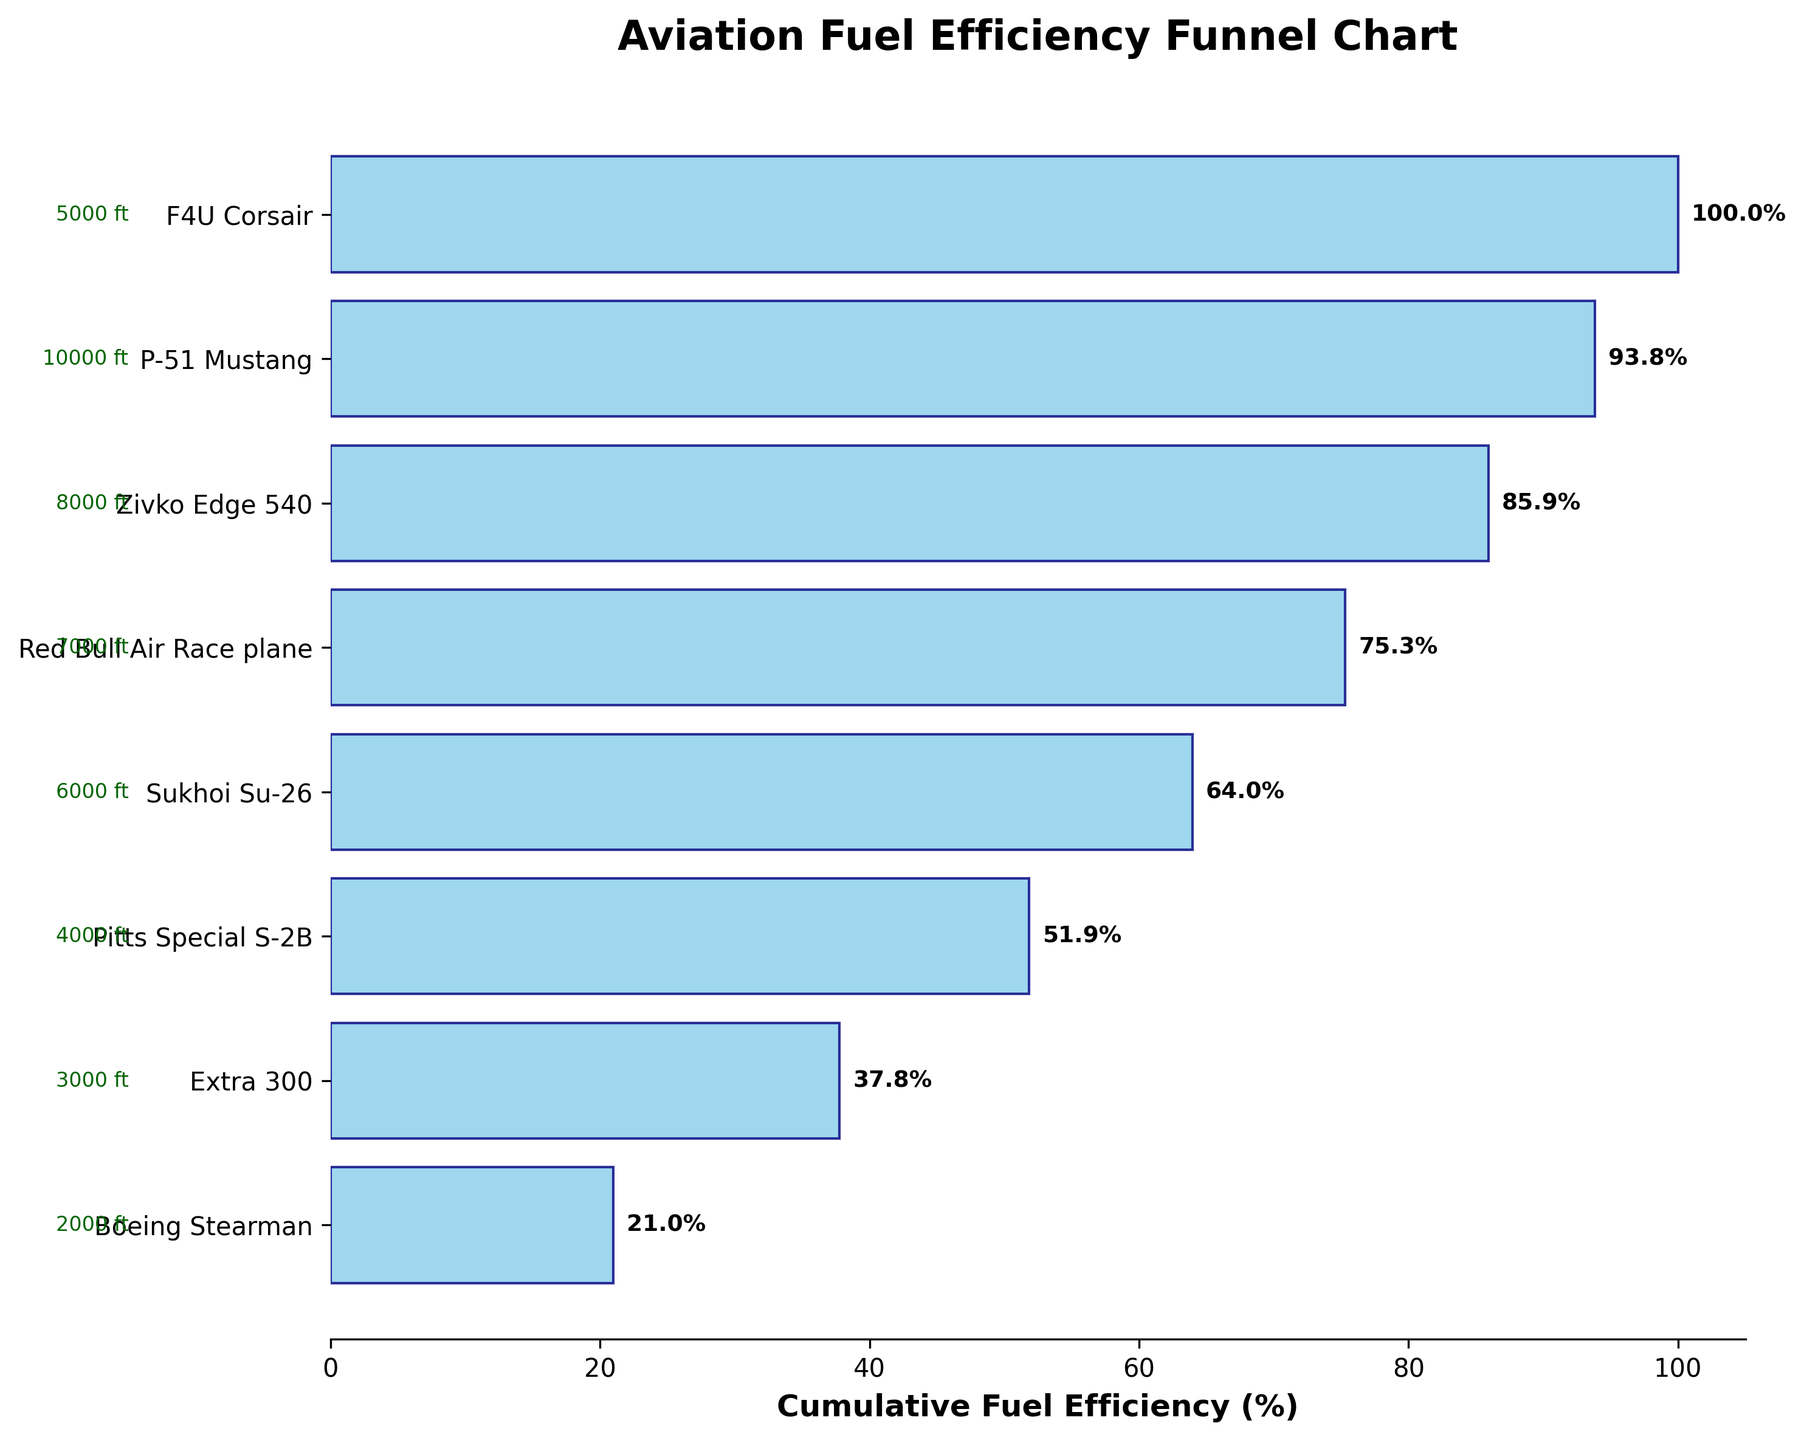What's the title of the figure? The title of the figure is located at the top and is typically the most prominent text.
Answer: Aviation Fuel Efficiency Funnel Chart How many aircraft models are represented in the funnel chart? There are eight horizontal bars on the chart, each representing a different aircraft model.
Answer: 8 Which aircraft model has the highest cumulative fuel efficiency percentage? The aircraft model at the top of the funnel chart has the highest cumulative fuel efficiency percentage.
Answer: Boeing Stearman What is the flight altitude of the Pitts Special S-2B? The flight altitude is listed next to the aircraft model name on the y-axis.
Answer: 4000 ft What cumulative fuel efficiency percentage does the Red Bull Air Race plane contribute? The cumulative percentage for each model is shown at the end of each bar. The Red Bull Air Race plane is listed near the bottom.
Answer: 91.1% By how much does the fuel efficiency of the Zivko Edge 540 differ from the P-51 Mustang? Subtract the cumulative percentage of the P-51 Mustang from the Zivko Edge 540. The P-51 Mustang has approximately 51.6%, and the Zivko Edge 540 is around 86.0%.
Answer: 34.4% Which aircraft model has the lowest cumulative fuel efficiency percentage? The aircraft model at the bottom of the funnel chart has the lowest percentage.
Answer: F4U Corsair How does the flight altitude of the Extra 300 compare to that of the Sukhoi Su-26? Compare the listed flight altitudes next to the aircraft model names on the y-axis.
Answer: 3000 ft is lower than 6000 ft What's the average cumulative fuel efficiency percentage of the top three aircraft models? The top three aircraft models are Boeing Stearman, Extra 300, and Pitts Special S-2B. Their percentages are approximately 100%, 79.7%, and 67.6%, respectively. (100 + 79.7 + 67.6) / 3 = 82.43%
Answer: 82.43% How many aircraft models have a flight altitude of 5000 ft or higher? Examine the flight altitudes next to the aircraft model names on the y-axis and count those that are 5000 ft or higher. These are F4U Corsair (5000 ft), Sukhoi Su-26 (6000 ft), Red Bull Air Race plane (7000 ft), and Zivko Edge 540 (8000 ft).
Answer: 4 